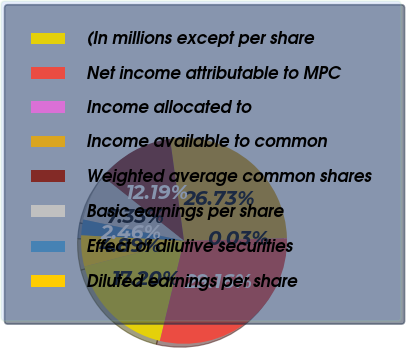Convert chart to OTSL. <chart><loc_0><loc_0><loc_500><loc_500><pie_chart><fcel>(In millions except per share<fcel>Net income attributable to MPC<fcel>Income allocated to<fcel>Income available to common<fcel>Weighted average common shares<fcel>Basic earnings per share<fcel>Effect of dilutive securities<fcel>Diluted earnings per share<nl><fcel>17.2%<fcel>29.16%<fcel>0.03%<fcel>26.73%<fcel>12.19%<fcel>7.33%<fcel>2.46%<fcel>4.89%<nl></chart> 